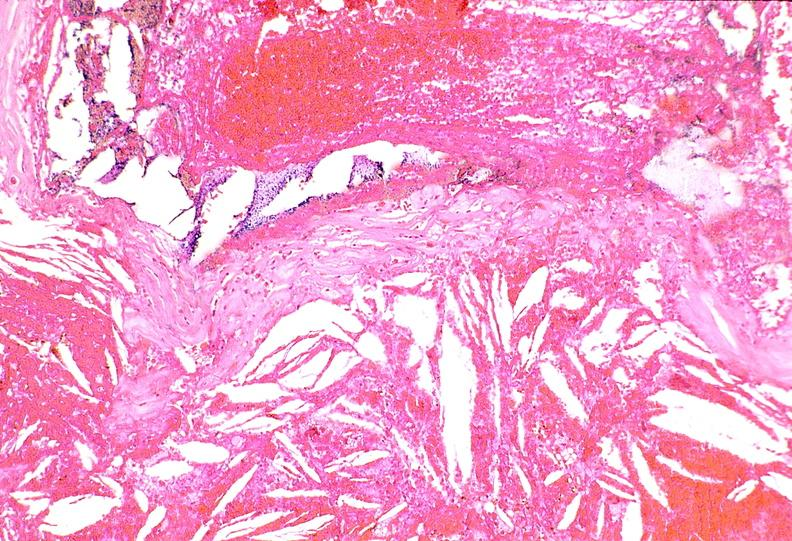s vasculature present?
Answer the question using a single word or phrase. Yes 